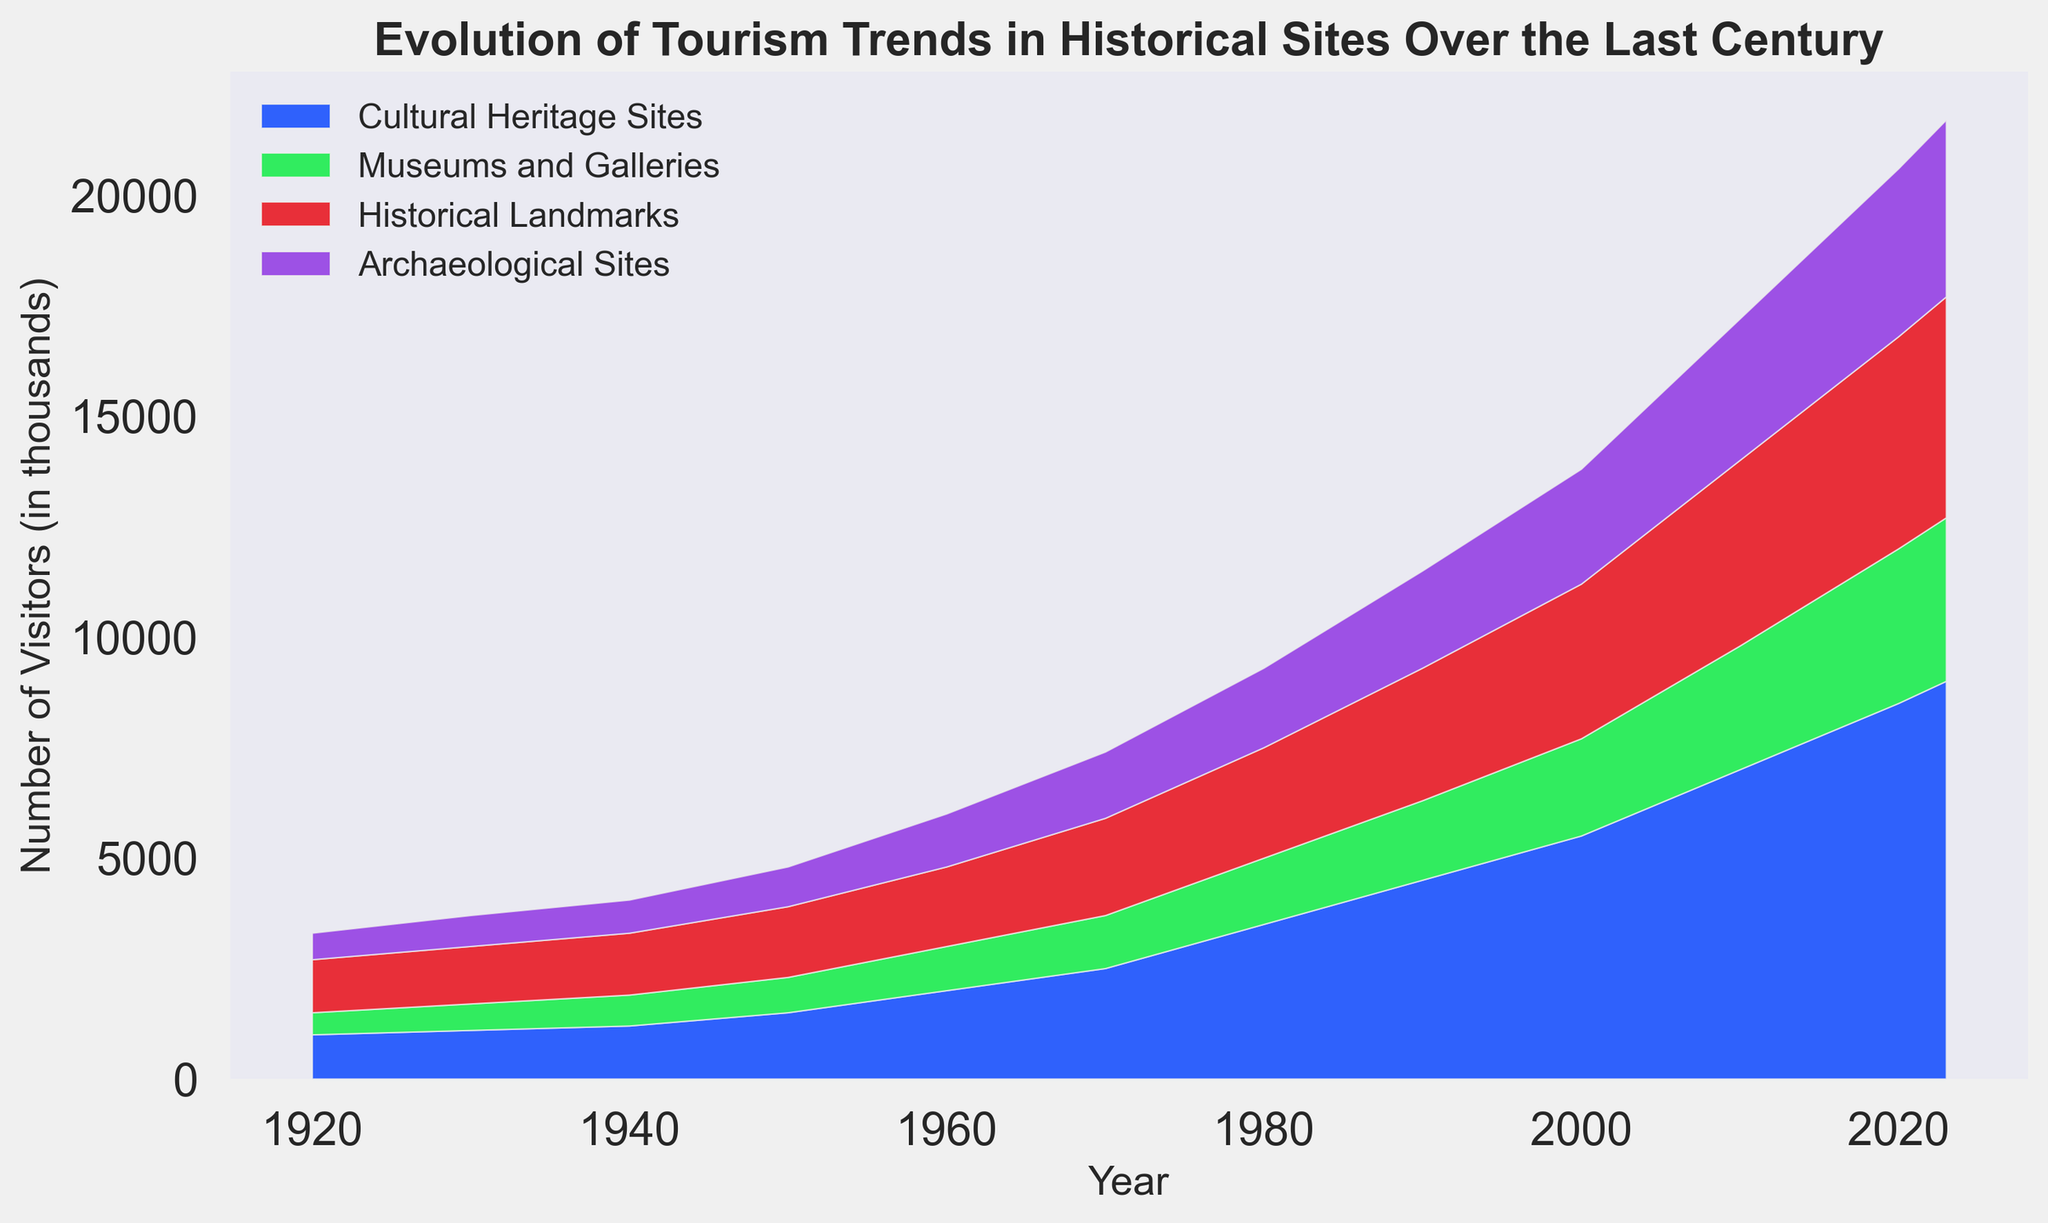Which category had the highest number of visitors in 2023? By looking at the plotted area for each category in 2023, "Cultural Heritage Sites" has the tallest and therefore the largest area.
Answer: Cultural Heritage Sites How many more visitors did Cultural Heritage Sites have compared to Museums and Galleries in 2023? The number of visitors to Cultural Heritage Sites in 2023 is 9000, and for Museums and Galleries, it is 3700. The difference is 9000 - 3700.
Answer: 5300 Which period saw the greatest increase in visitors to Historical Landmarks? Observing the changes over time, the greatest increase for Historical Landmarks seems to occur between 1960 and 1970 as indicated by a steep rise in the area.
Answer: 1960-1970 What was the total number of visitors for all categories combined in 1980? Sum the visitors in each category for the year 1980: 3500 (Cultural Heritage Sites) + 1500 (Museums and Galleries) + 2500 (Historical Landmarks) + 1800 (Archaeological Sites).
Answer: 9300 Between which years did Museums and Galleries experience a consistent increase in visitors without any decline? By examining the chart, from 1920 to 2023, Museums and Galleries consistently increased every decade.
Answer: 1920-2023 How many visitors did Archaeological Sites attract in 2000, and how did this compare to Museums and Galleries in the same year? In 2000, Archaeological Sites had 2600 visitors, while Museums and Galleries had 2200. Archaeological Sites had 2600 - 2200 = 400 more visitors.
Answer: 400 more When did Historical Landmarks first reach 3000 visitors? By following the area representing Historical Landmarks, they reached 3000 visitors in the year 1990.
Answer: 1990 What is the average number of visitors for Cultural Heritage Sites between 1920 and 2023? Sum the visitors from 1920 to 2023 for Cultural Heritage Sites: 1000 + 1100 + 1200 + 1500 + 2000 + 2500 + 3500 + 4500 + 5500 + 7000 + 8500 + 9000 = 50300. There are 12 data points, so the average is 50300 / 12.
Answer: Approximately 4191.67 What is the percentage increase in visitors to Cultural Heritage Sites from 1920 to 2023? In 1920, Cultural Heritage Sites had 1000 visitors, and in 2023, 9000 visitors. The increase is 9000 - 1000 = 8000. The percentage increase is (8000/1000) * 100.
Answer: 800% Which category almost doubled its visitors from 2010 to 2023? By looking at the area chart, "Cultural Heritage Sites" show a noticeable increase from 7000 in 2010 to 9000 in 2023, indicating it did not almost double. "Museums and Galleries" increased from 2800 to 3700, which is also not a doubling. "Historical Landmarks" and "Archaeological Sites" also did not double. Therefore, none of the categories exactly doubled their visitors.
Answer: None 